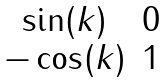<formula> <loc_0><loc_0><loc_500><loc_500>\begin{matrix} \sin ( k ) & 0 \\ - \cos ( k ) & 1 \end{matrix}</formula> 